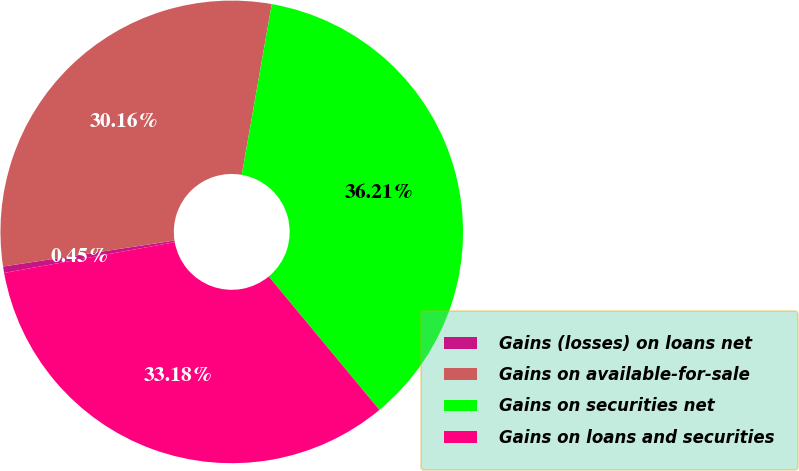Convert chart to OTSL. <chart><loc_0><loc_0><loc_500><loc_500><pie_chart><fcel>Gains (losses) on loans net<fcel>Gains on available-for-sale<fcel>Gains on securities net<fcel>Gains on loans and securities<nl><fcel>0.45%<fcel>30.16%<fcel>36.21%<fcel>33.18%<nl></chart> 